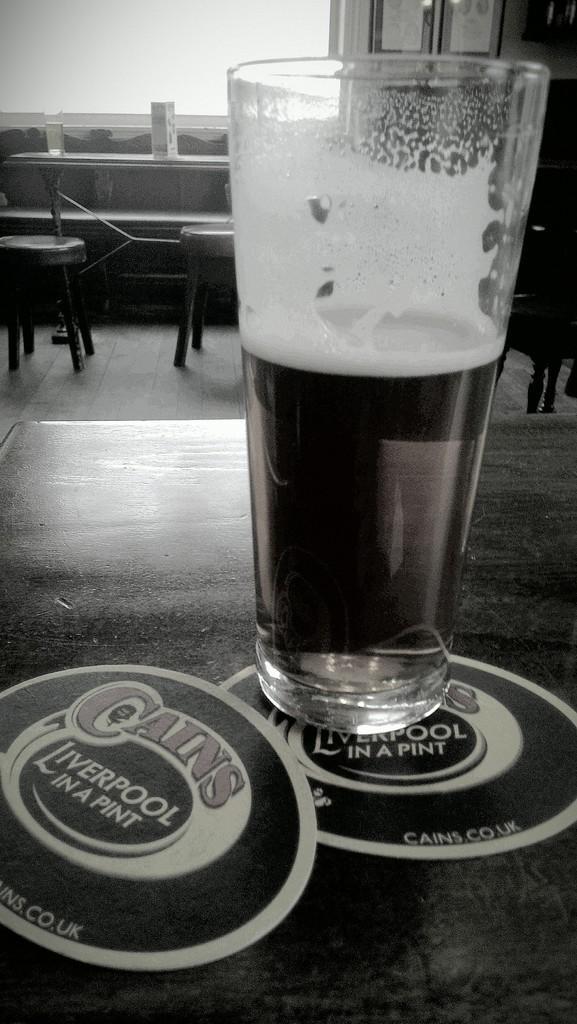In one or two sentences, can you explain what this image depicts? In this picture there is a glass of wine in the table with some labels and at the back ground there is a chair, table ,window, frames attached to the wall. 